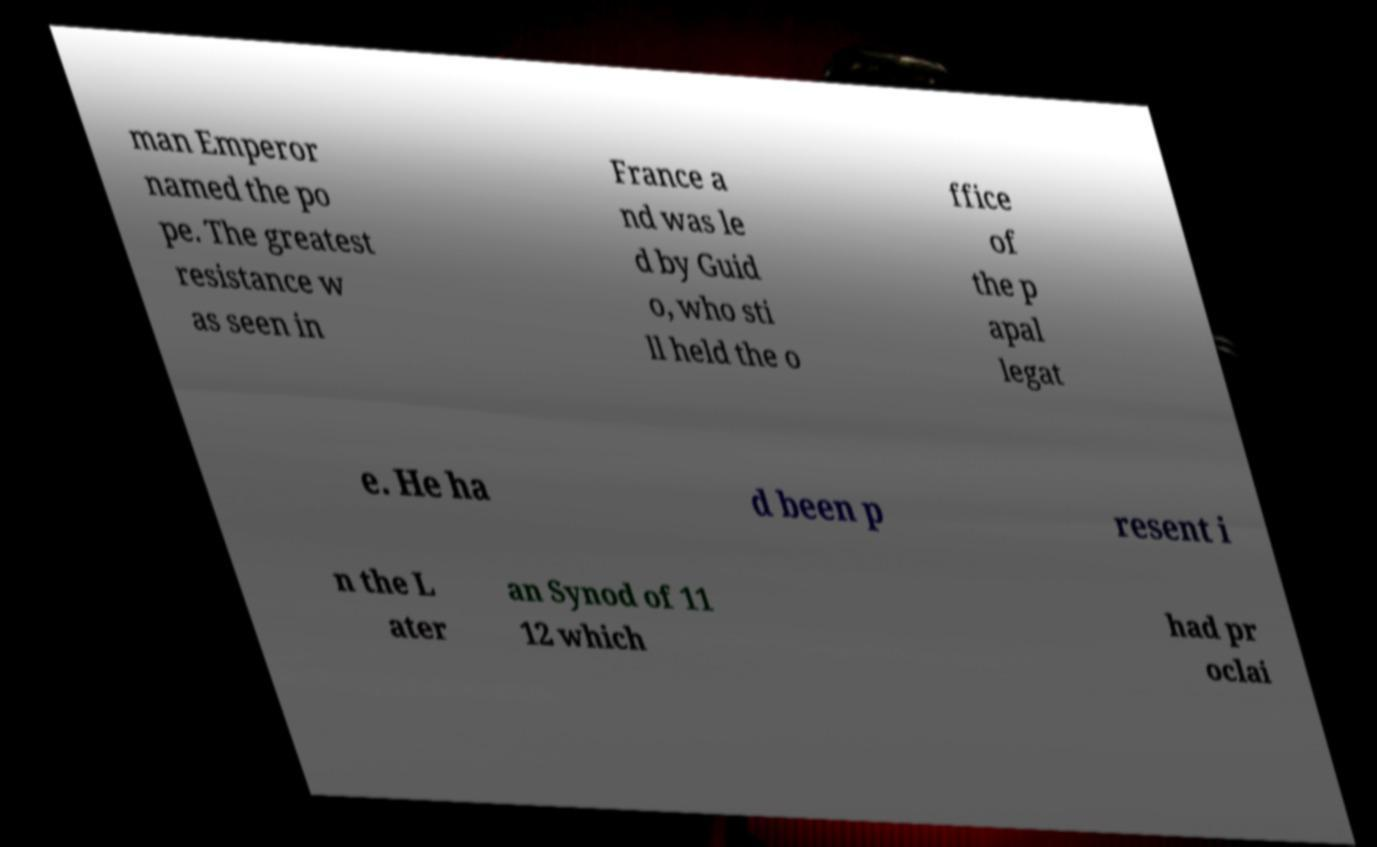Could you extract and type out the text from this image? man Emperor named the po pe. The greatest resistance w as seen in France a nd was le d by Guid o, who sti ll held the o ffice of the p apal legat e. He ha d been p resent i n the L ater an Synod of 11 12 which had pr oclai 